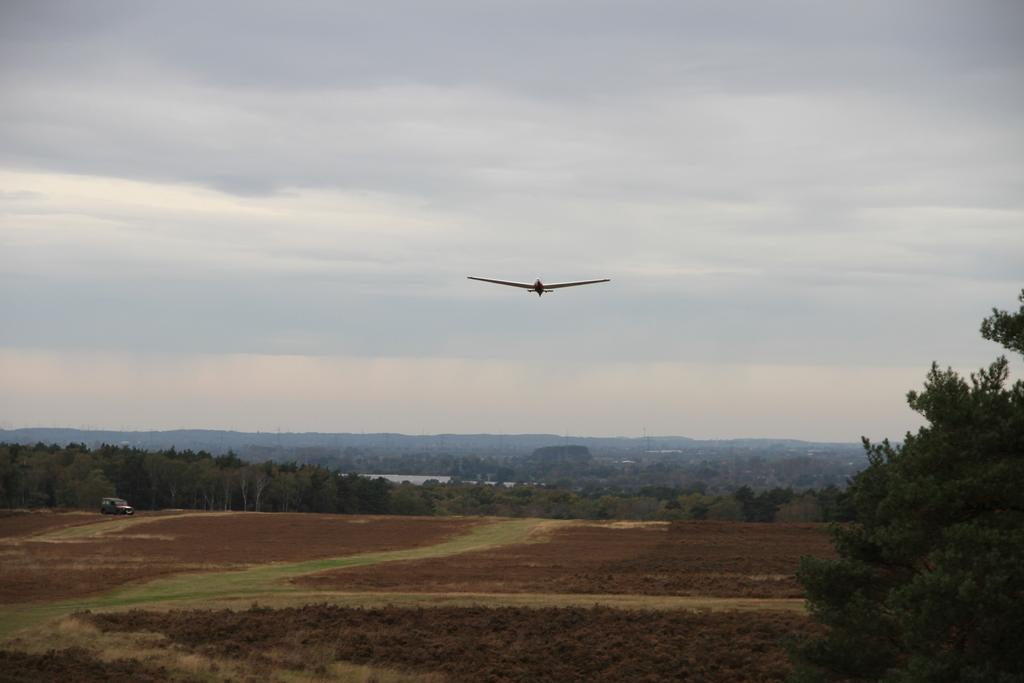Describe this image in one or two sentences. In this image, I can see the trees and plants on the ground. On the right side of the image, there is a vehicle. I can see an airplane flying in the sky. 